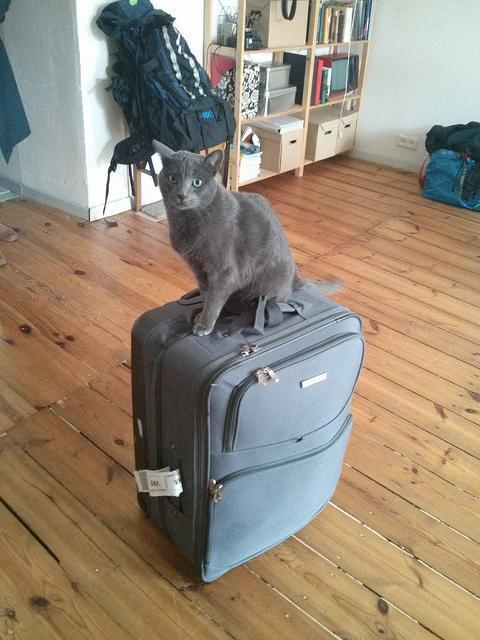How many backpacks are there?
Give a very brief answer. 2. 